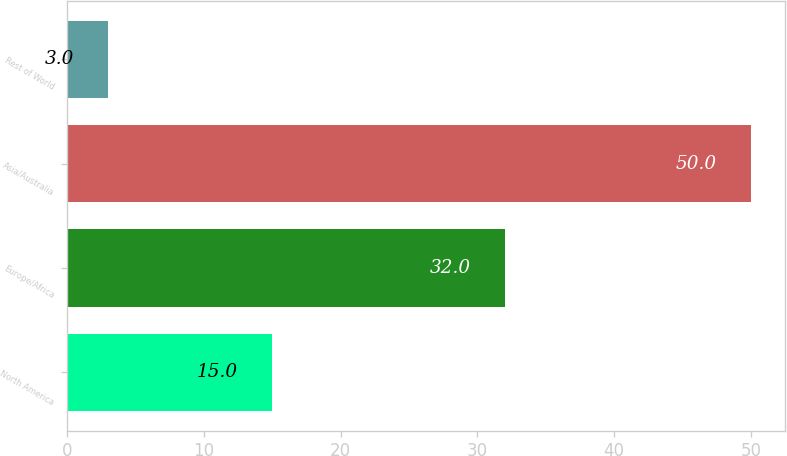<chart> <loc_0><loc_0><loc_500><loc_500><bar_chart><fcel>North America<fcel>Europe/Africa<fcel>Asia/Australia<fcel>Rest of World<nl><fcel>15<fcel>32<fcel>50<fcel>3<nl></chart> 